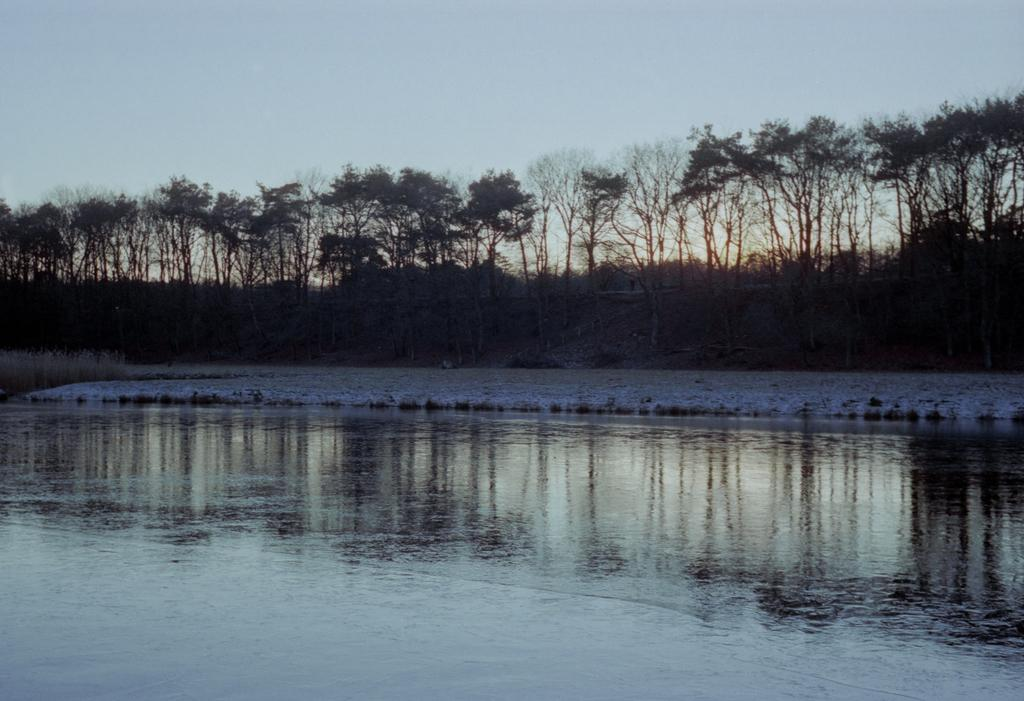What is visible in the image? Water is visible in the image. What can be seen in the background of the image? There are trees and a clear sky in the background of the image. How many screws can be seen holding the blade in place in the image? There are no screws or blades present in the image; it features water and a background with trees and a clear sky. 